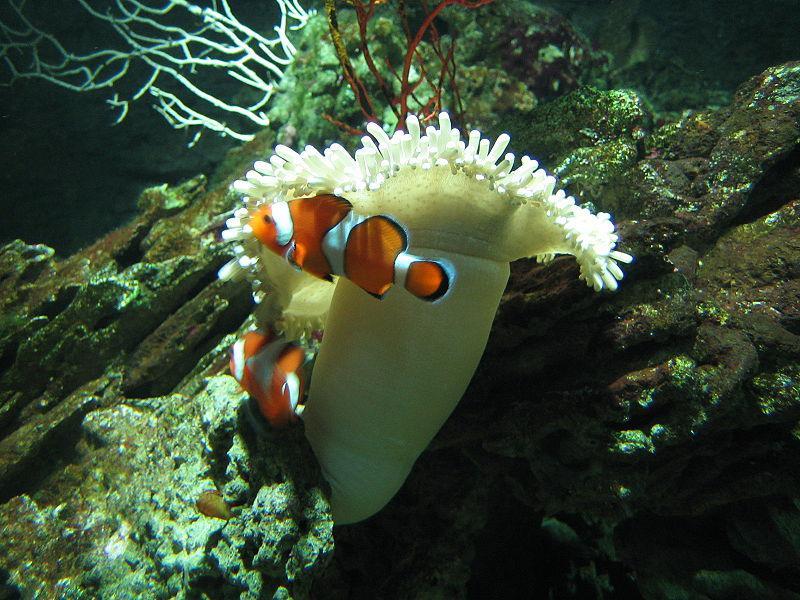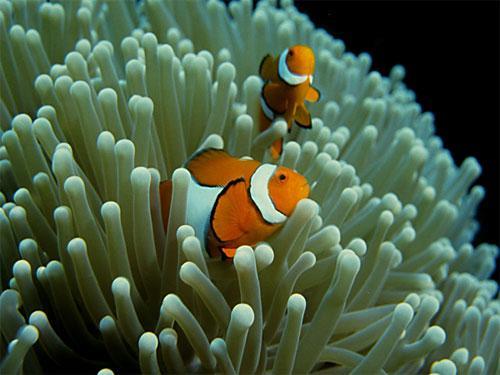The first image is the image on the left, the second image is the image on the right. Considering the images on both sides, is "There are two fish in the picture on the left." valid? Answer yes or no. Yes. 